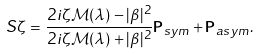Convert formula to latex. <formula><loc_0><loc_0><loc_500><loc_500>S { \zeta } = \frac { 2 i \zeta { \mathcal { M } } ( \lambda ) - | \beta | ^ { 2 } } { 2 i \zeta { \mathcal { M } ( \lambda ) } + | \beta | ^ { 2 } } { \mathbf P } _ { s y m } + { \mathbf P } _ { a s y m } .</formula> 